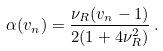<formula> <loc_0><loc_0><loc_500><loc_500>\alpha ( v _ { n } ) = \frac { \nu _ { R } ( v _ { n } - 1 ) } { 2 ( 1 + 4 \nu _ { R } ^ { 2 } ) } \, .</formula> 